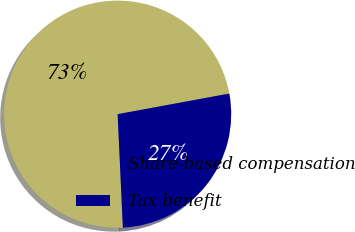<chart> <loc_0><loc_0><loc_500><loc_500><pie_chart><fcel>Share-based compensation<fcel>Tax benefit<nl><fcel>72.83%<fcel>27.17%<nl></chart> 